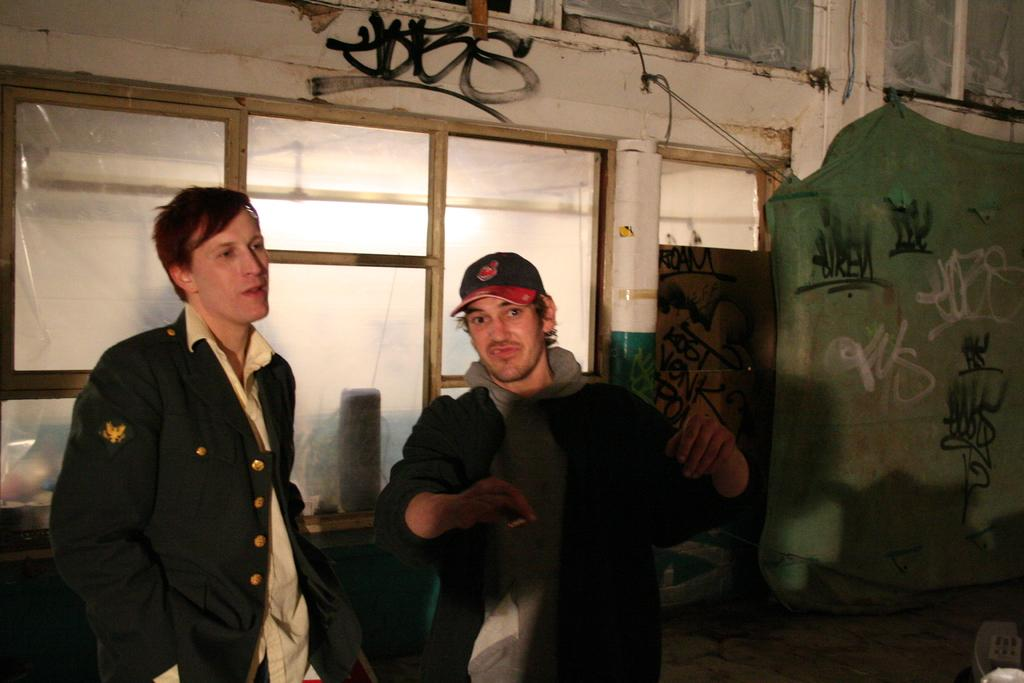How many people are in the image? There are two persons in the image. What are the persons wearing? The persons are wearing clothes. What can be seen in the middle of the image? There is a window in the middle of the image. What is located on the right side of the image? There is a cloth on the right side of the image. How many children are playing with the cabbage in the image? There are no children or cabbage present in the image. 